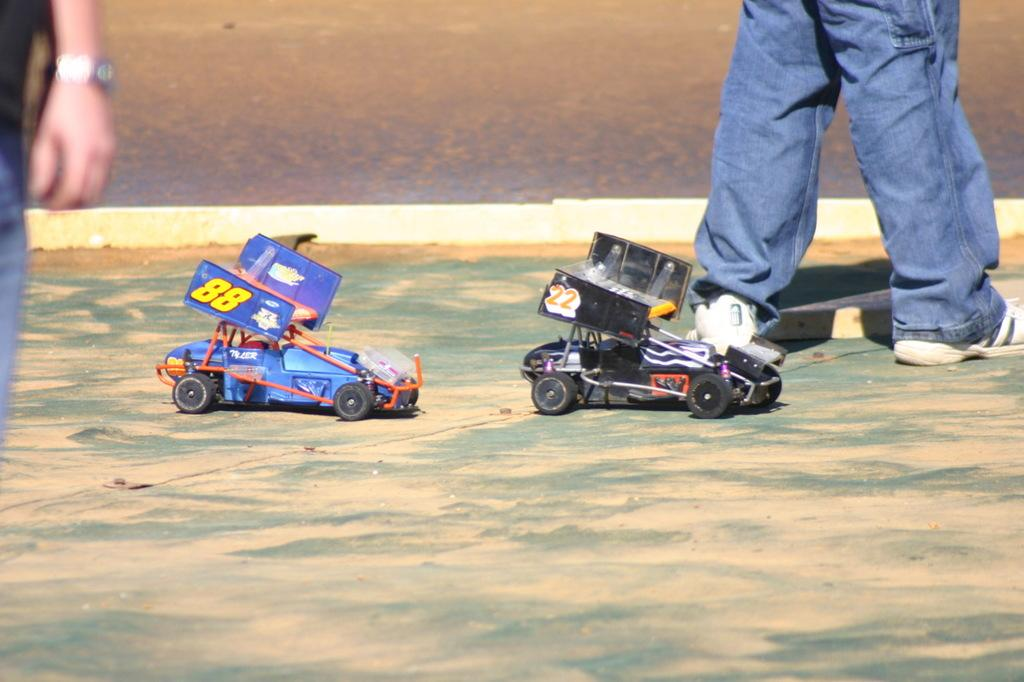What can be seen at the bottom of the image? There are legs of a person in the image. What objects are present on the surface in the image? There are two toy cars on the surface in the image. Can you describe the person on the left side of the image? There is another person on the left side of the image. How much money is being exchanged between the two people in the image? There is no mention of money or any exchange of money in the image. What type of selection is available for the toy cars in the image? There is no indication of a selection or variety of toy cars in the image; only two toy cars are visible. 